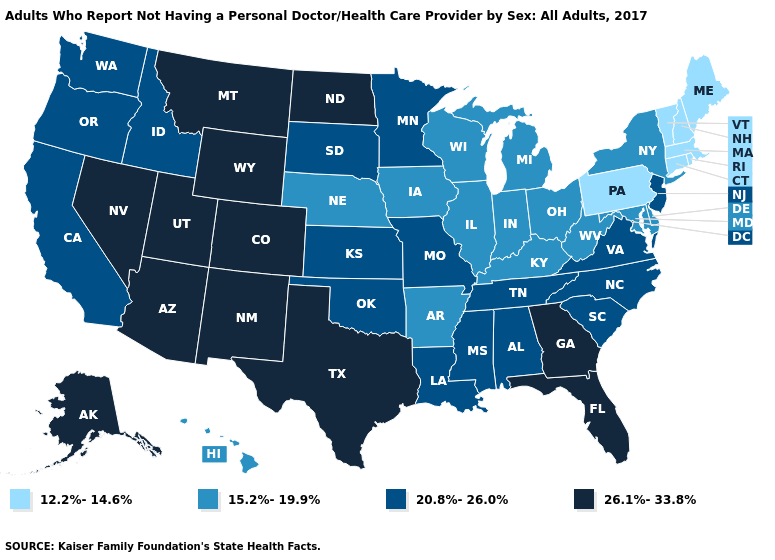Which states have the highest value in the USA?
Concise answer only. Alaska, Arizona, Colorado, Florida, Georgia, Montana, Nevada, New Mexico, North Dakota, Texas, Utah, Wyoming. Among the states that border Arizona , which have the highest value?
Write a very short answer. Colorado, Nevada, New Mexico, Utah. Which states have the lowest value in the Northeast?
Quick response, please. Connecticut, Maine, Massachusetts, New Hampshire, Pennsylvania, Rhode Island, Vermont. Name the states that have a value in the range 26.1%-33.8%?
Give a very brief answer. Alaska, Arizona, Colorado, Florida, Georgia, Montana, Nevada, New Mexico, North Dakota, Texas, Utah, Wyoming. Which states have the lowest value in the South?
Short answer required. Arkansas, Delaware, Kentucky, Maryland, West Virginia. Does Wisconsin have the same value as Indiana?
Keep it brief. Yes. What is the lowest value in the USA?
Write a very short answer. 12.2%-14.6%. What is the value of Nebraska?
Short answer required. 15.2%-19.9%. Does Oregon have the highest value in the West?
Give a very brief answer. No. Does Colorado have the highest value in the USA?
Concise answer only. Yes. Among the states that border California , does Arizona have the highest value?
Short answer required. Yes. What is the value of Missouri?
Give a very brief answer. 20.8%-26.0%. What is the value of Utah?
Short answer required. 26.1%-33.8%. Name the states that have a value in the range 12.2%-14.6%?
Concise answer only. Connecticut, Maine, Massachusetts, New Hampshire, Pennsylvania, Rhode Island, Vermont. What is the value of North Dakota?
Be succinct. 26.1%-33.8%. 